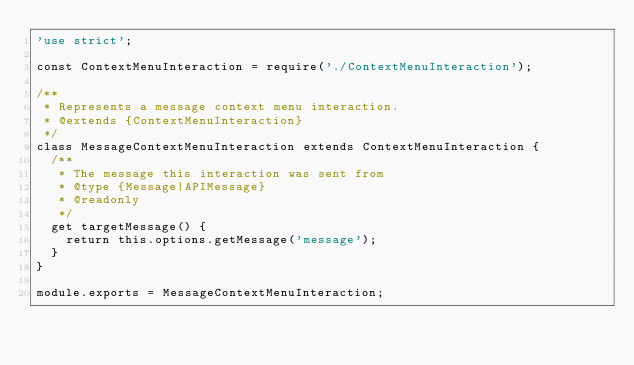<code> <loc_0><loc_0><loc_500><loc_500><_JavaScript_>'use strict';

const ContextMenuInteraction = require('./ContextMenuInteraction');

/**
 * Represents a message context menu interaction.
 * @extends {ContextMenuInteraction}
 */
class MessageContextMenuInteraction extends ContextMenuInteraction {
  /**
   * The message this interaction was sent from
   * @type {Message|APIMessage}
   * @readonly
   */
  get targetMessage() {
    return this.options.getMessage('message');
  }
}

module.exports = MessageContextMenuInteraction;
</code> 